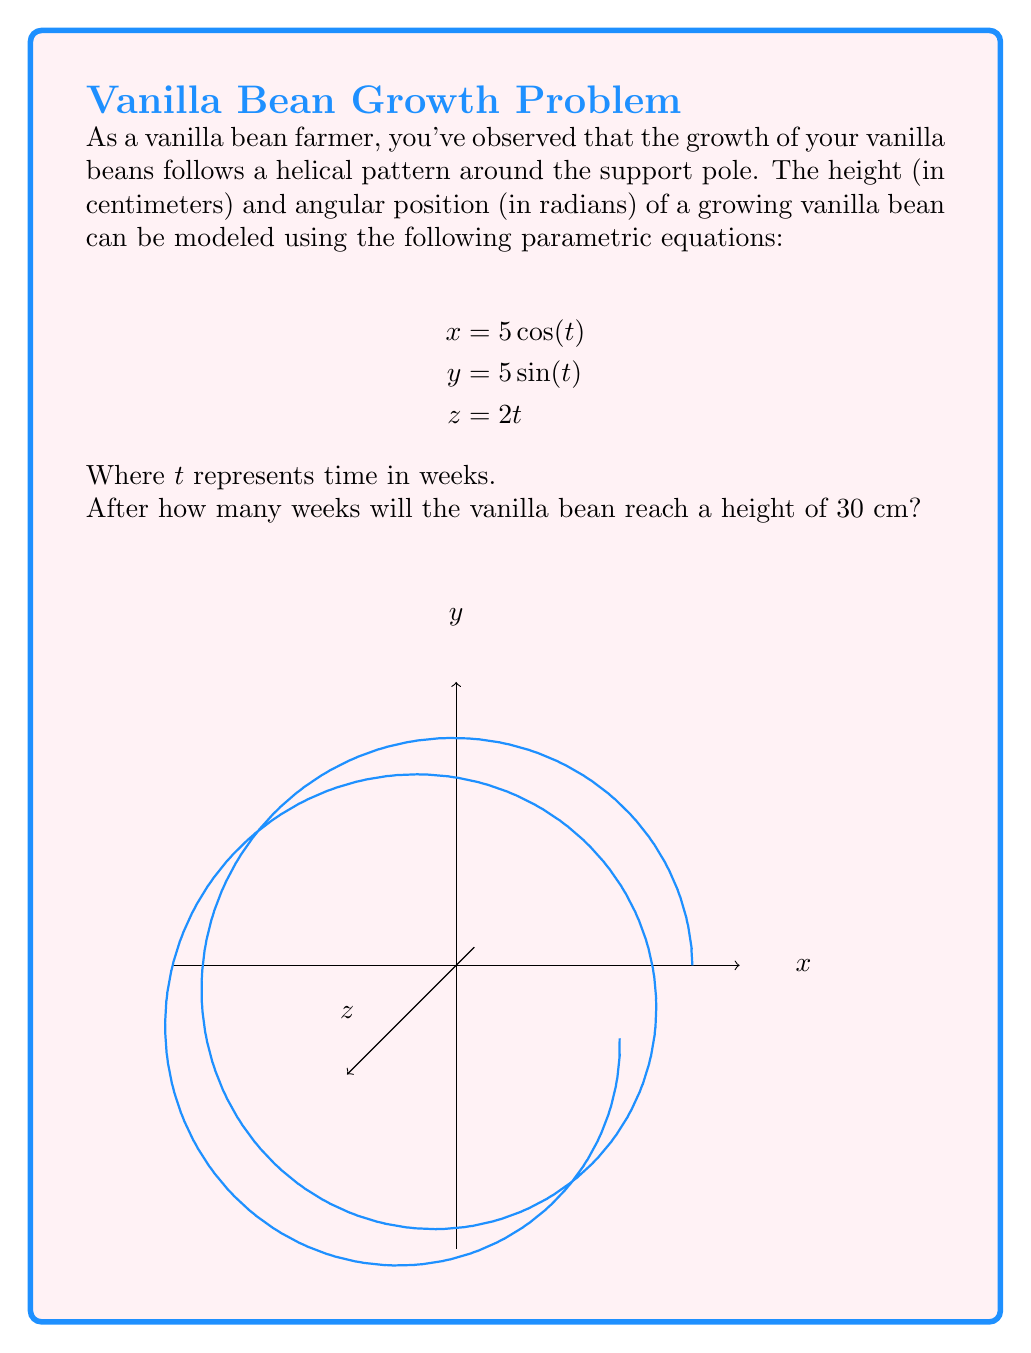Could you help me with this problem? Let's approach this step-by-step:

1) The height of the vanilla bean is represented by the $z$ equation:
   $$z = 2t$$

2) We want to find when the height ($z$) reaches 30 cm. So, we set up the equation:
   $$30 = 2t$$

3) To solve for $t$, we divide both sides by 2:
   $$\frac{30}{2} = t$$
   $$15 = t$$

4) Remember that $t$ represents time in weeks.

5) Therefore, the vanilla bean will reach a height of 30 cm after 15 weeks.

Note: The $x$ and $y$ equations describe the circular motion around the support pole, while the $z$ equation describes the vertical growth over time.
Answer: 15 weeks 